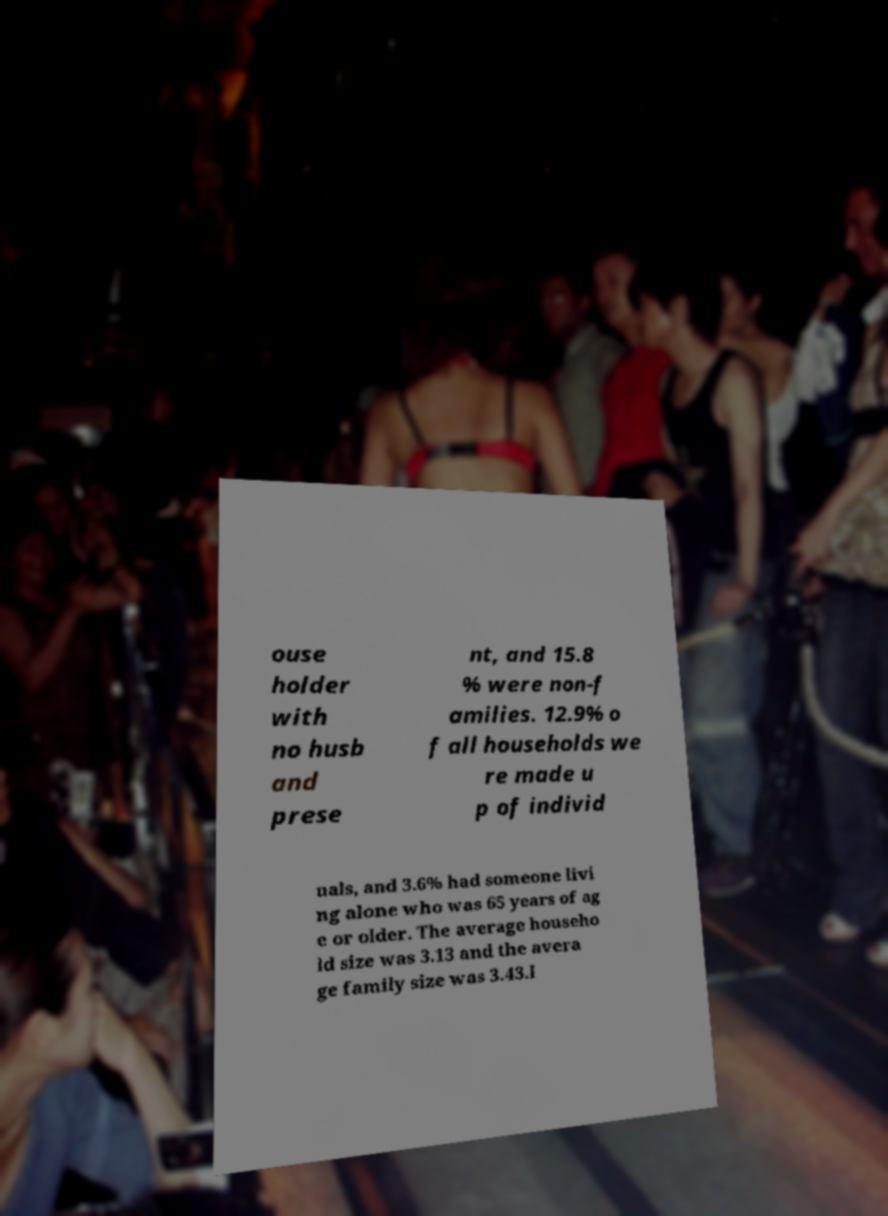For documentation purposes, I need the text within this image transcribed. Could you provide that? ouse holder with no husb and prese nt, and 15.8 % were non-f amilies. 12.9% o f all households we re made u p of individ uals, and 3.6% had someone livi ng alone who was 65 years of ag e or older. The average househo ld size was 3.13 and the avera ge family size was 3.43.I 